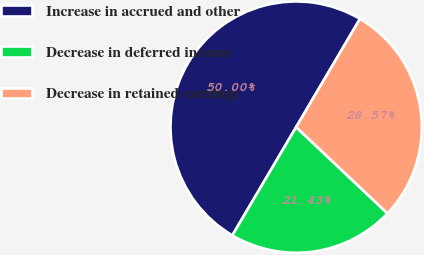Convert chart to OTSL. <chart><loc_0><loc_0><loc_500><loc_500><pie_chart><fcel>Increase in accrued and other<fcel>Decrease in deferred income<fcel>Decrease in retained earnings<nl><fcel>50.0%<fcel>21.43%<fcel>28.57%<nl></chart> 